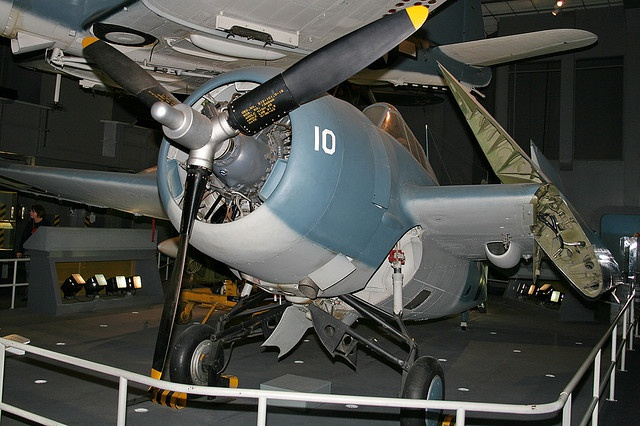Describe the objects in this image and their specific colors. I can see a airplane in gray, black, and darkgray tones in this image. 